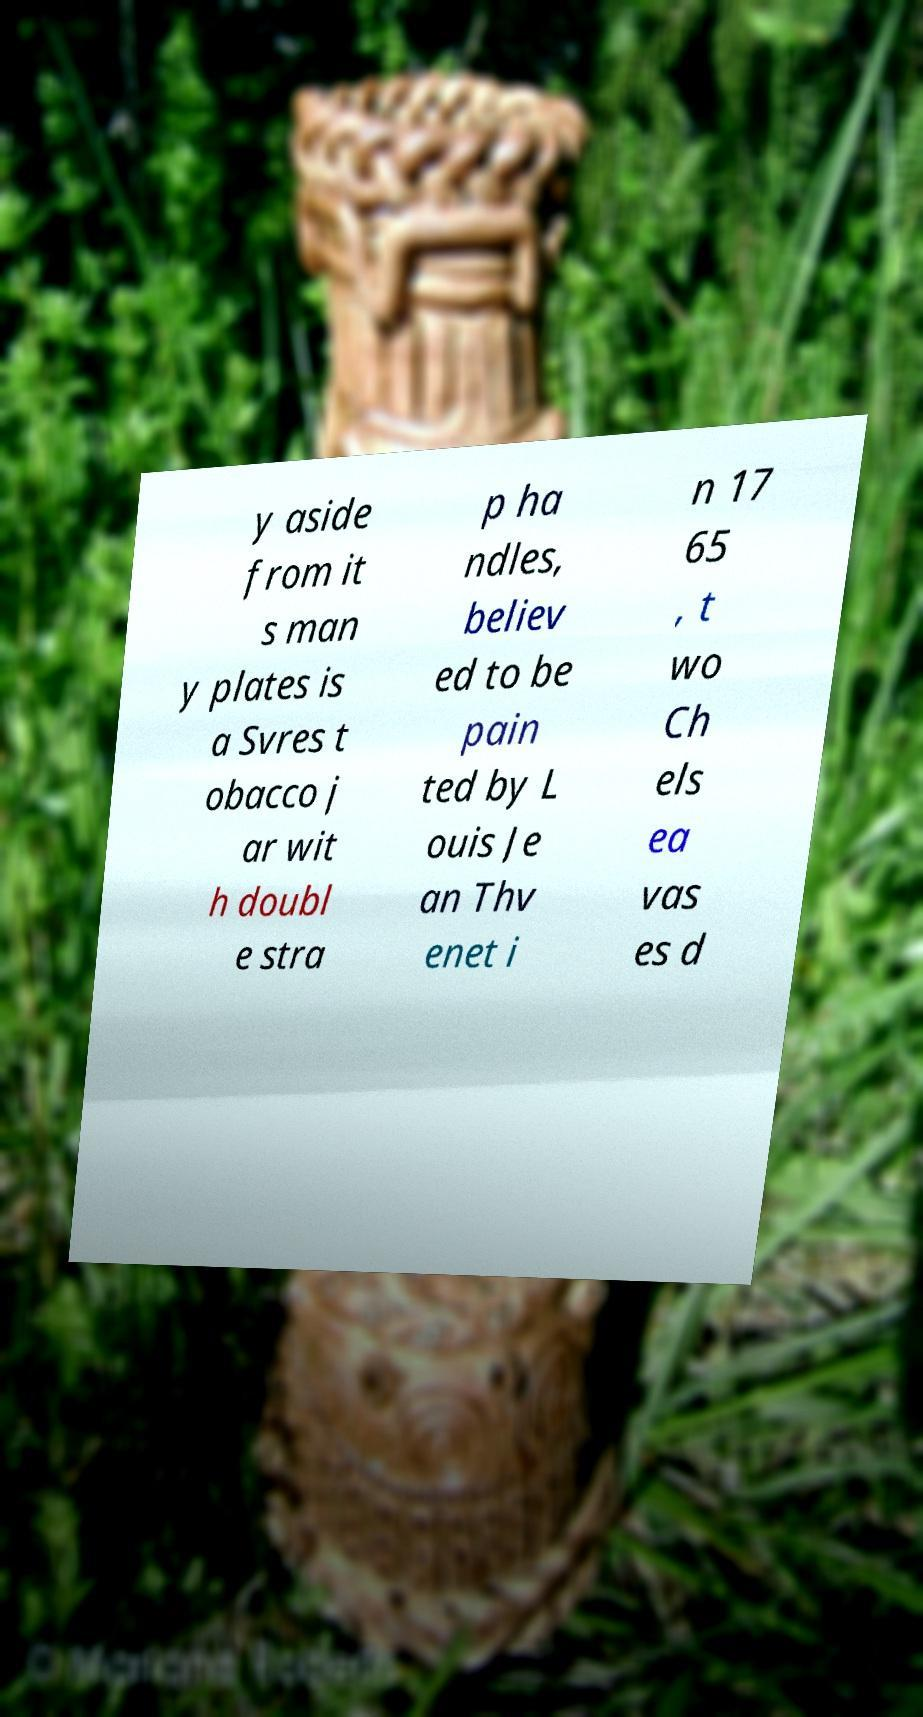Can you accurately transcribe the text from the provided image for me? y aside from it s man y plates is a Svres t obacco j ar wit h doubl e stra p ha ndles, believ ed to be pain ted by L ouis Je an Thv enet i n 17 65 , t wo Ch els ea vas es d 